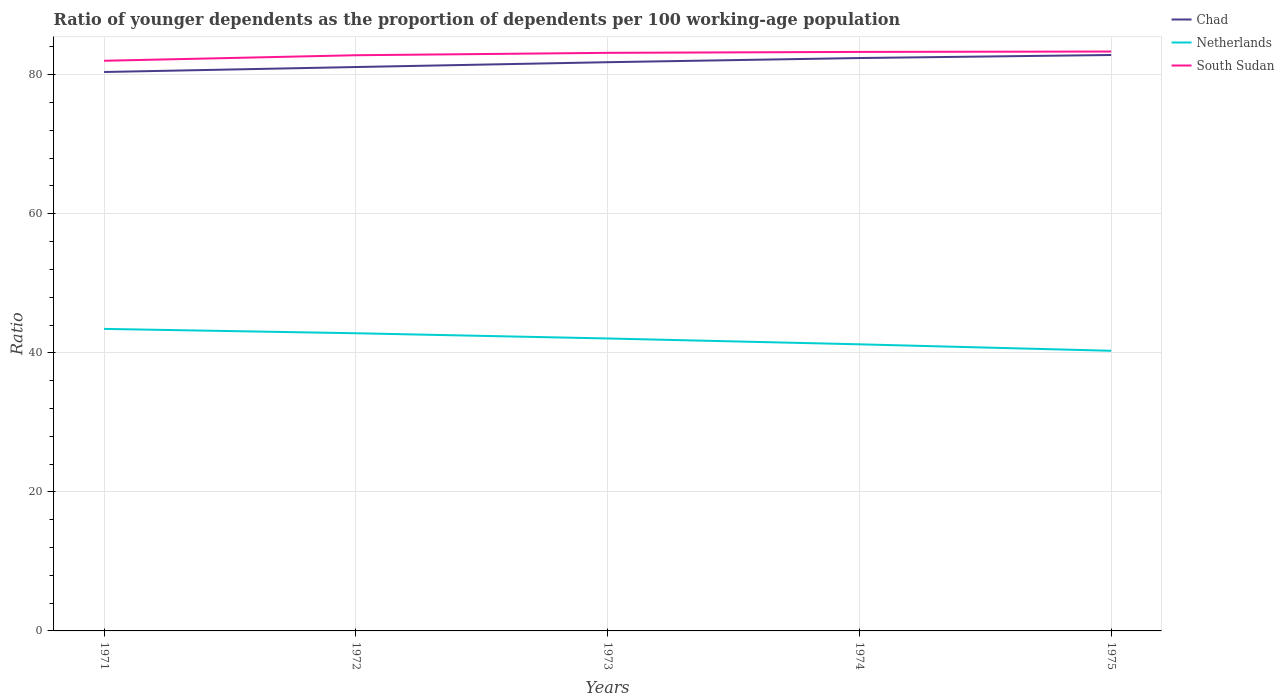Does the line corresponding to Chad intersect with the line corresponding to South Sudan?
Provide a short and direct response. No. Across all years, what is the maximum age dependency ratio(young) in Chad?
Your answer should be very brief. 80.4. In which year was the age dependency ratio(young) in Chad maximum?
Offer a very short reply. 1971. What is the total age dependency ratio(young) in Netherlands in the graph?
Offer a terse response. 1.59. What is the difference between the highest and the second highest age dependency ratio(young) in Chad?
Provide a succinct answer. 2.45. How many years are there in the graph?
Offer a very short reply. 5. What is the difference between two consecutive major ticks on the Y-axis?
Give a very brief answer. 20. Are the values on the major ticks of Y-axis written in scientific E-notation?
Provide a succinct answer. No. Does the graph contain any zero values?
Your answer should be very brief. No. Does the graph contain grids?
Offer a terse response. Yes. How are the legend labels stacked?
Provide a short and direct response. Vertical. What is the title of the graph?
Ensure brevity in your answer.  Ratio of younger dependents as the proportion of dependents per 100 working-age population. What is the label or title of the Y-axis?
Your response must be concise. Ratio. What is the Ratio in Chad in 1971?
Provide a short and direct response. 80.4. What is the Ratio in Netherlands in 1971?
Ensure brevity in your answer.  43.45. What is the Ratio in South Sudan in 1971?
Your answer should be very brief. 82.01. What is the Ratio in Chad in 1972?
Ensure brevity in your answer.  81.11. What is the Ratio of Netherlands in 1972?
Provide a succinct answer. 42.82. What is the Ratio in South Sudan in 1972?
Your answer should be compact. 82.81. What is the Ratio of Chad in 1973?
Ensure brevity in your answer.  81.81. What is the Ratio in Netherlands in 1973?
Provide a short and direct response. 42.07. What is the Ratio in South Sudan in 1973?
Offer a very short reply. 83.15. What is the Ratio of Chad in 1974?
Give a very brief answer. 82.41. What is the Ratio of Netherlands in 1974?
Provide a succinct answer. 41.23. What is the Ratio of South Sudan in 1974?
Ensure brevity in your answer.  83.29. What is the Ratio in Chad in 1975?
Provide a short and direct response. 82.84. What is the Ratio in Netherlands in 1975?
Provide a succinct answer. 40.3. What is the Ratio of South Sudan in 1975?
Provide a succinct answer. 83.34. Across all years, what is the maximum Ratio in Chad?
Offer a terse response. 82.84. Across all years, what is the maximum Ratio of Netherlands?
Ensure brevity in your answer.  43.45. Across all years, what is the maximum Ratio in South Sudan?
Provide a short and direct response. 83.34. Across all years, what is the minimum Ratio of Chad?
Keep it short and to the point. 80.4. Across all years, what is the minimum Ratio of Netherlands?
Keep it short and to the point. 40.3. Across all years, what is the minimum Ratio of South Sudan?
Offer a very short reply. 82.01. What is the total Ratio of Chad in the graph?
Offer a very short reply. 408.56. What is the total Ratio in Netherlands in the graph?
Provide a succinct answer. 209.86. What is the total Ratio of South Sudan in the graph?
Provide a short and direct response. 414.6. What is the difference between the Ratio of Chad in 1971 and that in 1972?
Give a very brief answer. -0.71. What is the difference between the Ratio of Netherlands in 1971 and that in 1972?
Keep it short and to the point. 0.63. What is the difference between the Ratio in South Sudan in 1971 and that in 1972?
Offer a very short reply. -0.79. What is the difference between the Ratio of Chad in 1971 and that in 1973?
Make the answer very short. -1.41. What is the difference between the Ratio in Netherlands in 1971 and that in 1973?
Make the answer very short. 1.38. What is the difference between the Ratio in South Sudan in 1971 and that in 1973?
Keep it short and to the point. -1.14. What is the difference between the Ratio of Chad in 1971 and that in 1974?
Your answer should be compact. -2.01. What is the difference between the Ratio in Netherlands in 1971 and that in 1974?
Ensure brevity in your answer.  2.22. What is the difference between the Ratio of South Sudan in 1971 and that in 1974?
Offer a very short reply. -1.28. What is the difference between the Ratio of Chad in 1971 and that in 1975?
Your answer should be very brief. -2.45. What is the difference between the Ratio in Netherlands in 1971 and that in 1975?
Your answer should be compact. 3.15. What is the difference between the Ratio in South Sudan in 1971 and that in 1975?
Make the answer very short. -1.33. What is the difference between the Ratio of Chad in 1972 and that in 1973?
Offer a terse response. -0.7. What is the difference between the Ratio of Netherlands in 1972 and that in 1973?
Your answer should be very brief. 0.75. What is the difference between the Ratio in South Sudan in 1972 and that in 1973?
Give a very brief answer. -0.34. What is the difference between the Ratio of Chad in 1972 and that in 1974?
Offer a terse response. -1.3. What is the difference between the Ratio in Netherlands in 1972 and that in 1974?
Offer a very short reply. 1.59. What is the difference between the Ratio in South Sudan in 1972 and that in 1974?
Your answer should be very brief. -0.48. What is the difference between the Ratio in Chad in 1972 and that in 1975?
Make the answer very short. -1.73. What is the difference between the Ratio in Netherlands in 1972 and that in 1975?
Provide a succinct answer. 2.52. What is the difference between the Ratio of South Sudan in 1972 and that in 1975?
Provide a succinct answer. -0.53. What is the difference between the Ratio of Chad in 1973 and that in 1974?
Your response must be concise. -0.6. What is the difference between the Ratio in Netherlands in 1973 and that in 1974?
Make the answer very short. 0.84. What is the difference between the Ratio in South Sudan in 1973 and that in 1974?
Make the answer very short. -0.14. What is the difference between the Ratio of Chad in 1973 and that in 1975?
Provide a short and direct response. -1.04. What is the difference between the Ratio in Netherlands in 1973 and that in 1975?
Give a very brief answer. 1.77. What is the difference between the Ratio in South Sudan in 1973 and that in 1975?
Offer a terse response. -0.19. What is the difference between the Ratio of Chad in 1974 and that in 1975?
Provide a short and direct response. -0.44. What is the difference between the Ratio in Netherlands in 1974 and that in 1975?
Make the answer very short. 0.93. What is the difference between the Ratio in South Sudan in 1974 and that in 1975?
Offer a terse response. -0.05. What is the difference between the Ratio in Chad in 1971 and the Ratio in Netherlands in 1972?
Provide a succinct answer. 37.58. What is the difference between the Ratio of Chad in 1971 and the Ratio of South Sudan in 1972?
Offer a very short reply. -2.41. What is the difference between the Ratio in Netherlands in 1971 and the Ratio in South Sudan in 1972?
Your response must be concise. -39.36. What is the difference between the Ratio in Chad in 1971 and the Ratio in Netherlands in 1973?
Offer a very short reply. 38.33. What is the difference between the Ratio in Chad in 1971 and the Ratio in South Sudan in 1973?
Ensure brevity in your answer.  -2.76. What is the difference between the Ratio of Netherlands in 1971 and the Ratio of South Sudan in 1973?
Offer a terse response. -39.71. What is the difference between the Ratio of Chad in 1971 and the Ratio of Netherlands in 1974?
Give a very brief answer. 39.17. What is the difference between the Ratio in Chad in 1971 and the Ratio in South Sudan in 1974?
Your answer should be very brief. -2.89. What is the difference between the Ratio of Netherlands in 1971 and the Ratio of South Sudan in 1974?
Offer a very short reply. -39.84. What is the difference between the Ratio in Chad in 1971 and the Ratio in Netherlands in 1975?
Offer a terse response. 40.1. What is the difference between the Ratio of Chad in 1971 and the Ratio of South Sudan in 1975?
Give a very brief answer. -2.94. What is the difference between the Ratio in Netherlands in 1971 and the Ratio in South Sudan in 1975?
Provide a succinct answer. -39.89. What is the difference between the Ratio of Chad in 1972 and the Ratio of Netherlands in 1973?
Make the answer very short. 39.04. What is the difference between the Ratio in Chad in 1972 and the Ratio in South Sudan in 1973?
Make the answer very short. -2.04. What is the difference between the Ratio of Netherlands in 1972 and the Ratio of South Sudan in 1973?
Provide a short and direct response. -40.33. What is the difference between the Ratio in Chad in 1972 and the Ratio in Netherlands in 1974?
Your answer should be very brief. 39.88. What is the difference between the Ratio of Chad in 1972 and the Ratio of South Sudan in 1974?
Give a very brief answer. -2.18. What is the difference between the Ratio in Netherlands in 1972 and the Ratio in South Sudan in 1974?
Offer a terse response. -40.47. What is the difference between the Ratio in Chad in 1972 and the Ratio in Netherlands in 1975?
Your response must be concise. 40.81. What is the difference between the Ratio of Chad in 1972 and the Ratio of South Sudan in 1975?
Keep it short and to the point. -2.23. What is the difference between the Ratio in Netherlands in 1972 and the Ratio in South Sudan in 1975?
Give a very brief answer. -40.52. What is the difference between the Ratio of Chad in 1973 and the Ratio of Netherlands in 1974?
Your answer should be very brief. 40.58. What is the difference between the Ratio in Chad in 1973 and the Ratio in South Sudan in 1974?
Give a very brief answer. -1.48. What is the difference between the Ratio in Netherlands in 1973 and the Ratio in South Sudan in 1974?
Your response must be concise. -41.22. What is the difference between the Ratio of Chad in 1973 and the Ratio of Netherlands in 1975?
Ensure brevity in your answer.  41.51. What is the difference between the Ratio of Chad in 1973 and the Ratio of South Sudan in 1975?
Your answer should be compact. -1.53. What is the difference between the Ratio of Netherlands in 1973 and the Ratio of South Sudan in 1975?
Offer a terse response. -41.27. What is the difference between the Ratio in Chad in 1974 and the Ratio in Netherlands in 1975?
Provide a succinct answer. 42.11. What is the difference between the Ratio of Chad in 1974 and the Ratio of South Sudan in 1975?
Ensure brevity in your answer.  -0.93. What is the difference between the Ratio in Netherlands in 1974 and the Ratio in South Sudan in 1975?
Ensure brevity in your answer.  -42.11. What is the average Ratio of Chad per year?
Keep it short and to the point. 81.71. What is the average Ratio of Netherlands per year?
Your answer should be compact. 41.97. What is the average Ratio of South Sudan per year?
Provide a short and direct response. 82.92. In the year 1971, what is the difference between the Ratio in Chad and Ratio in Netherlands?
Offer a very short reply. 36.95. In the year 1971, what is the difference between the Ratio of Chad and Ratio of South Sudan?
Provide a succinct answer. -1.62. In the year 1971, what is the difference between the Ratio in Netherlands and Ratio in South Sudan?
Your answer should be compact. -38.57. In the year 1972, what is the difference between the Ratio of Chad and Ratio of Netherlands?
Your answer should be compact. 38.29. In the year 1972, what is the difference between the Ratio in Chad and Ratio in South Sudan?
Your answer should be very brief. -1.7. In the year 1972, what is the difference between the Ratio of Netherlands and Ratio of South Sudan?
Your answer should be very brief. -39.99. In the year 1973, what is the difference between the Ratio of Chad and Ratio of Netherlands?
Provide a succinct answer. 39.74. In the year 1973, what is the difference between the Ratio in Chad and Ratio in South Sudan?
Make the answer very short. -1.34. In the year 1973, what is the difference between the Ratio of Netherlands and Ratio of South Sudan?
Your answer should be very brief. -41.08. In the year 1974, what is the difference between the Ratio of Chad and Ratio of Netherlands?
Your answer should be very brief. 41.18. In the year 1974, what is the difference between the Ratio of Chad and Ratio of South Sudan?
Your answer should be very brief. -0.88. In the year 1974, what is the difference between the Ratio in Netherlands and Ratio in South Sudan?
Your answer should be very brief. -42.06. In the year 1975, what is the difference between the Ratio in Chad and Ratio in Netherlands?
Your answer should be compact. 42.55. In the year 1975, what is the difference between the Ratio of Chad and Ratio of South Sudan?
Your response must be concise. -0.5. In the year 1975, what is the difference between the Ratio of Netherlands and Ratio of South Sudan?
Give a very brief answer. -43.04. What is the ratio of the Ratio of Chad in 1971 to that in 1972?
Your answer should be very brief. 0.99. What is the ratio of the Ratio of Netherlands in 1971 to that in 1972?
Your answer should be compact. 1.01. What is the ratio of the Ratio of Chad in 1971 to that in 1973?
Give a very brief answer. 0.98. What is the ratio of the Ratio in Netherlands in 1971 to that in 1973?
Provide a succinct answer. 1.03. What is the ratio of the Ratio of South Sudan in 1971 to that in 1973?
Provide a short and direct response. 0.99. What is the ratio of the Ratio of Chad in 1971 to that in 1974?
Give a very brief answer. 0.98. What is the ratio of the Ratio in Netherlands in 1971 to that in 1974?
Keep it short and to the point. 1.05. What is the ratio of the Ratio of South Sudan in 1971 to that in 1974?
Offer a very short reply. 0.98. What is the ratio of the Ratio of Chad in 1971 to that in 1975?
Give a very brief answer. 0.97. What is the ratio of the Ratio of Netherlands in 1971 to that in 1975?
Your answer should be compact. 1.08. What is the ratio of the Ratio in South Sudan in 1971 to that in 1975?
Your answer should be very brief. 0.98. What is the ratio of the Ratio of Netherlands in 1972 to that in 1973?
Your response must be concise. 1.02. What is the ratio of the Ratio in Chad in 1972 to that in 1974?
Provide a short and direct response. 0.98. What is the ratio of the Ratio in Netherlands in 1972 to that in 1974?
Make the answer very short. 1.04. What is the ratio of the Ratio of Chad in 1972 to that in 1975?
Keep it short and to the point. 0.98. What is the ratio of the Ratio of Netherlands in 1972 to that in 1975?
Keep it short and to the point. 1.06. What is the ratio of the Ratio of South Sudan in 1972 to that in 1975?
Provide a short and direct response. 0.99. What is the ratio of the Ratio in Netherlands in 1973 to that in 1974?
Ensure brevity in your answer.  1.02. What is the ratio of the Ratio in Chad in 1973 to that in 1975?
Keep it short and to the point. 0.99. What is the ratio of the Ratio of Netherlands in 1973 to that in 1975?
Give a very brief answer. 1.04. What is the ratio of the Ratio in South Sudan in 1973 to that in 1975?
Your answer should be very brief. 1. What is the ratio of the Ratio in Chad in 1974 to that in 1975?
Ensure brevity in your answer.  0.99. What is the ratio of the Ratio in Netherlands in 1974 to that in 1975?
Ensure brevity in your answer.  1.02. What is the ratio of the Ratio of South Sudan in 1974 to that in 1975?
Keep it short and to the point. 1. What is the difference between the highest and the second highest Ratio in Chad?
Your answer should be compact. 0.44. What is the difference between the highest and the second highest Ratio of Netherlands?
Give a very brief answer. 0.63. What is the difference between the highest and the second highest Ratio of South Sudan?
Your answer should be very brief. 0.05. What is the difference between the highest and the lowest Ratio in Chad?
Your answer should be compact. 2.45. What is the difference between the highest and the lowest Ratio in Netherlands?
Give a very brief answer. 3.15. What is the difference between the highest and the lowest Ratio in South Sudan?
Your response must be concise. 1.33. 